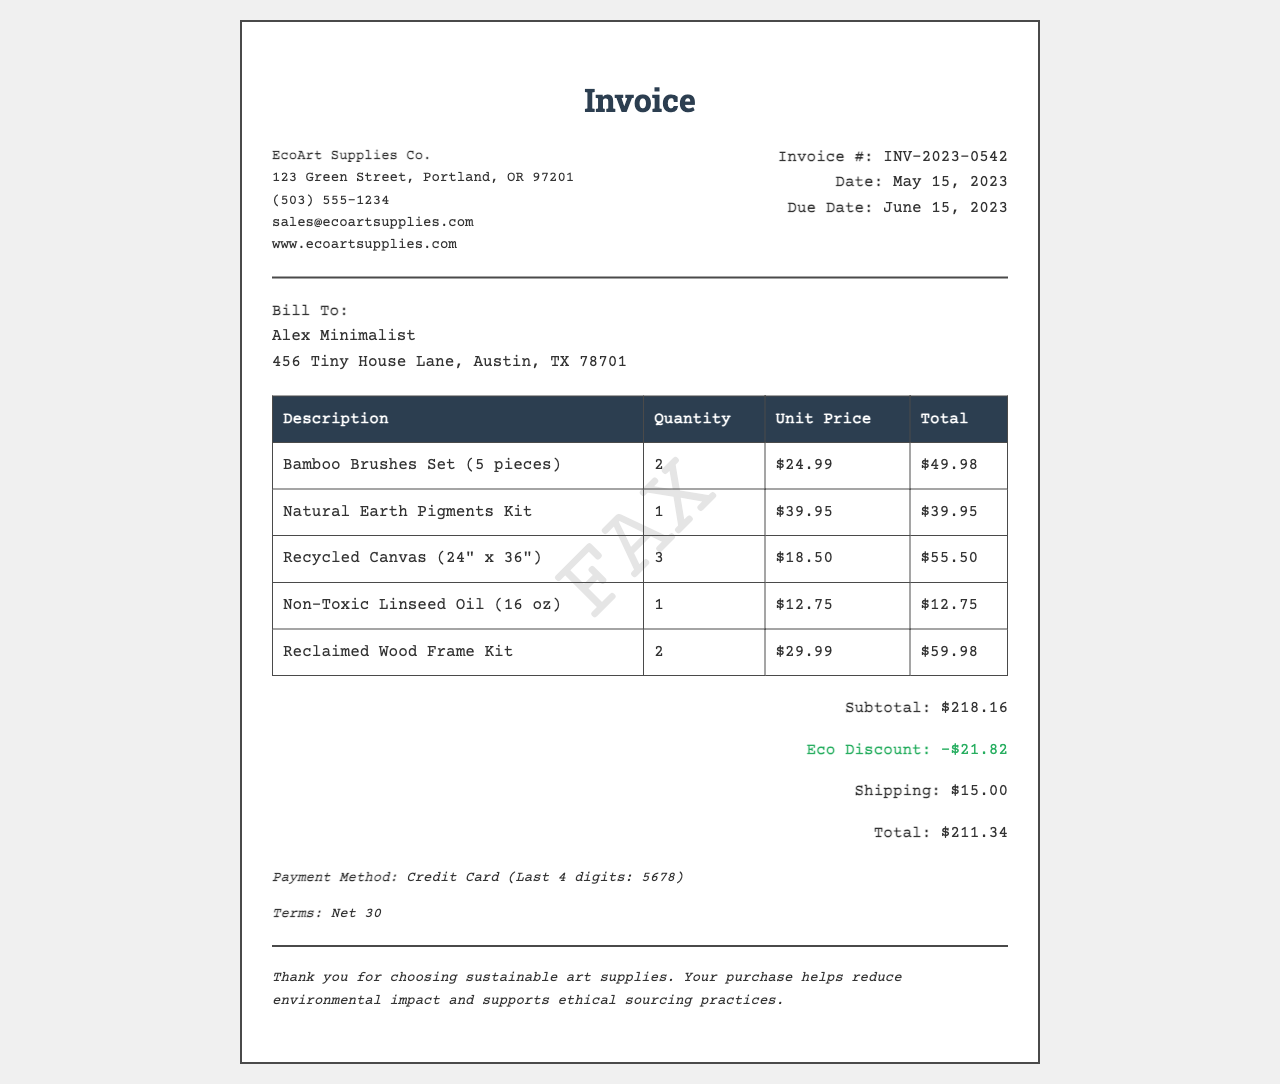What is the invoice number? The invoice number is indicated at the top of the invoice details section.
Answer: INV-2023-0542 What is the total amount due? The total amount due is listed in the totals section of the document.
Answer: $211.34 Who is the supplier of the art supplies? The supplier's information is provided in the header section of the invoice.
Answer: EcoArt Supplies Co When was the invoice created? The date the invoice was created is mentioned in the invoice details section.
Answer: May 15, 2023 What is the eco discount amount? The eco discount is clearly stated in the totals section of the document.
Answer: -$21.82 How many Bamboo Brushes Sets were purchased? This information is detailed in the items table under the quantity column for that specific item.
Answer: 2 What type of payment method was used? The payment method is noted in the payment info section of the invoice.
Answer: Credit Card What is the shipping cost? The shipping cost is provided in the totals section of the document.
Answer: $15.00 What is the due date for the invoice? The due date is indicated in the invoice details section along with the date created.
Answer: June 15, 2023 